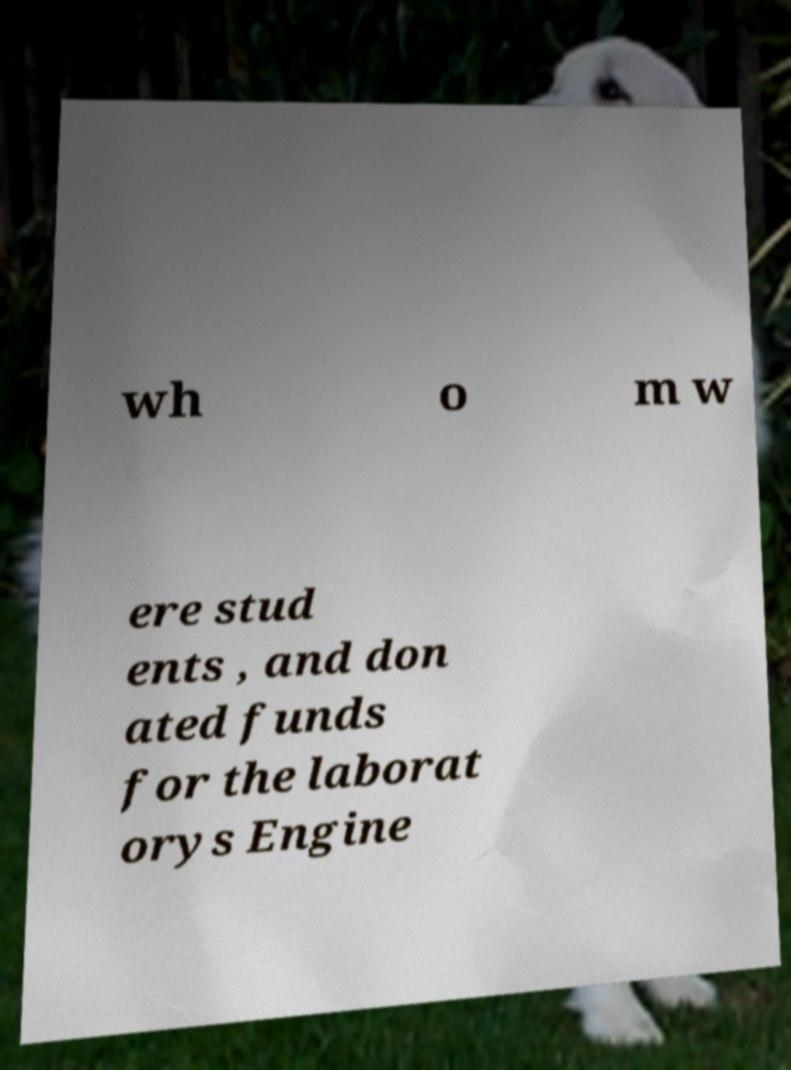Could you assist in decoding the text presented in this image and type it out clearly? wh o m w ere stud ents , and don ated funds for the laborat orys Engine 